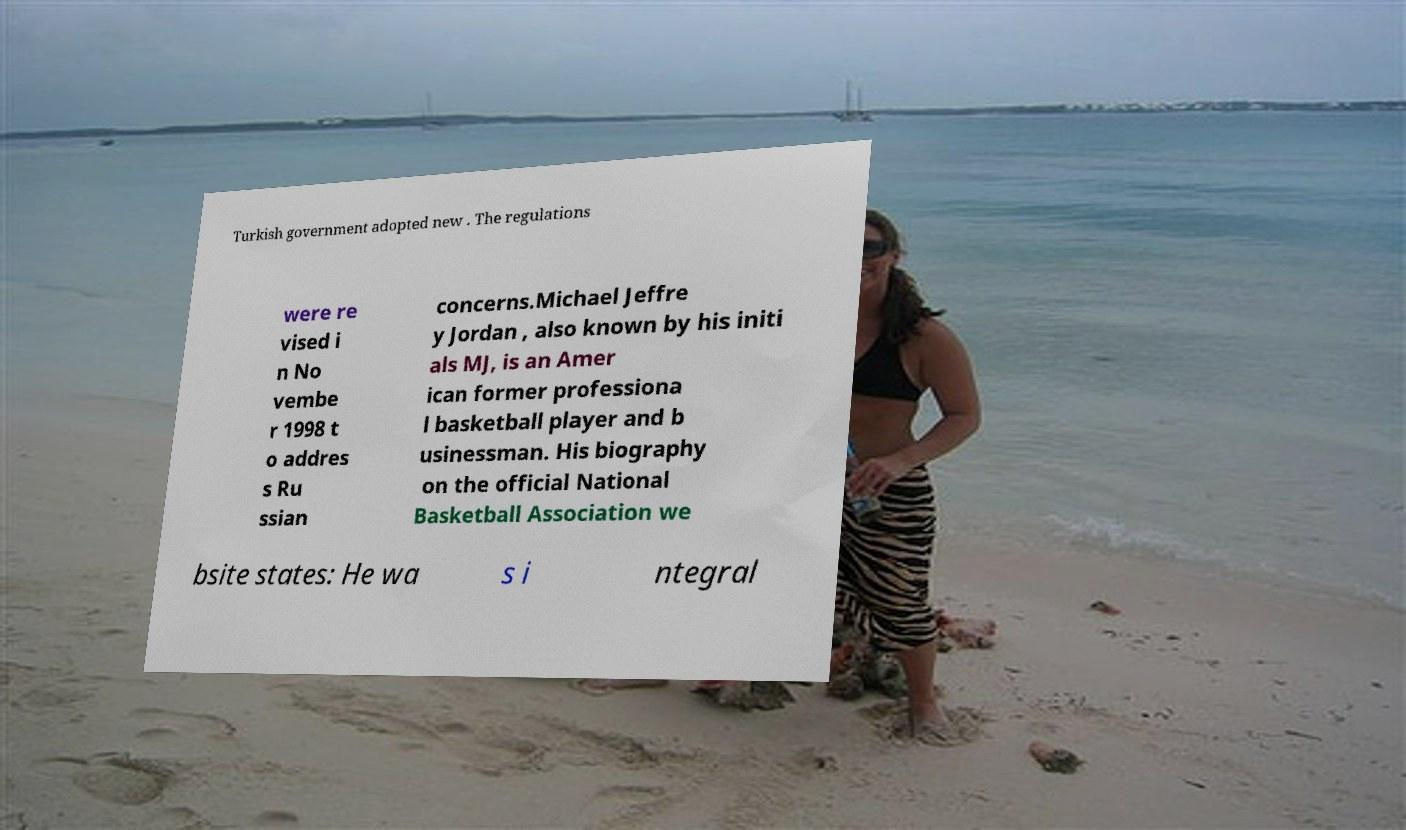I need the written content from this picture converted into text. Can you do that? Turkish government adopted new . The regulations were re vised i n No vembe r 1998 t o addres s Ru ssian concerns.Michael Jeffre y Jordan , also known by his initi als MJ, is an Amer ican former professiona l basketball player and b usinessman. His biography on the official National Basketball Association we bsite states: He wa s i ntegral 